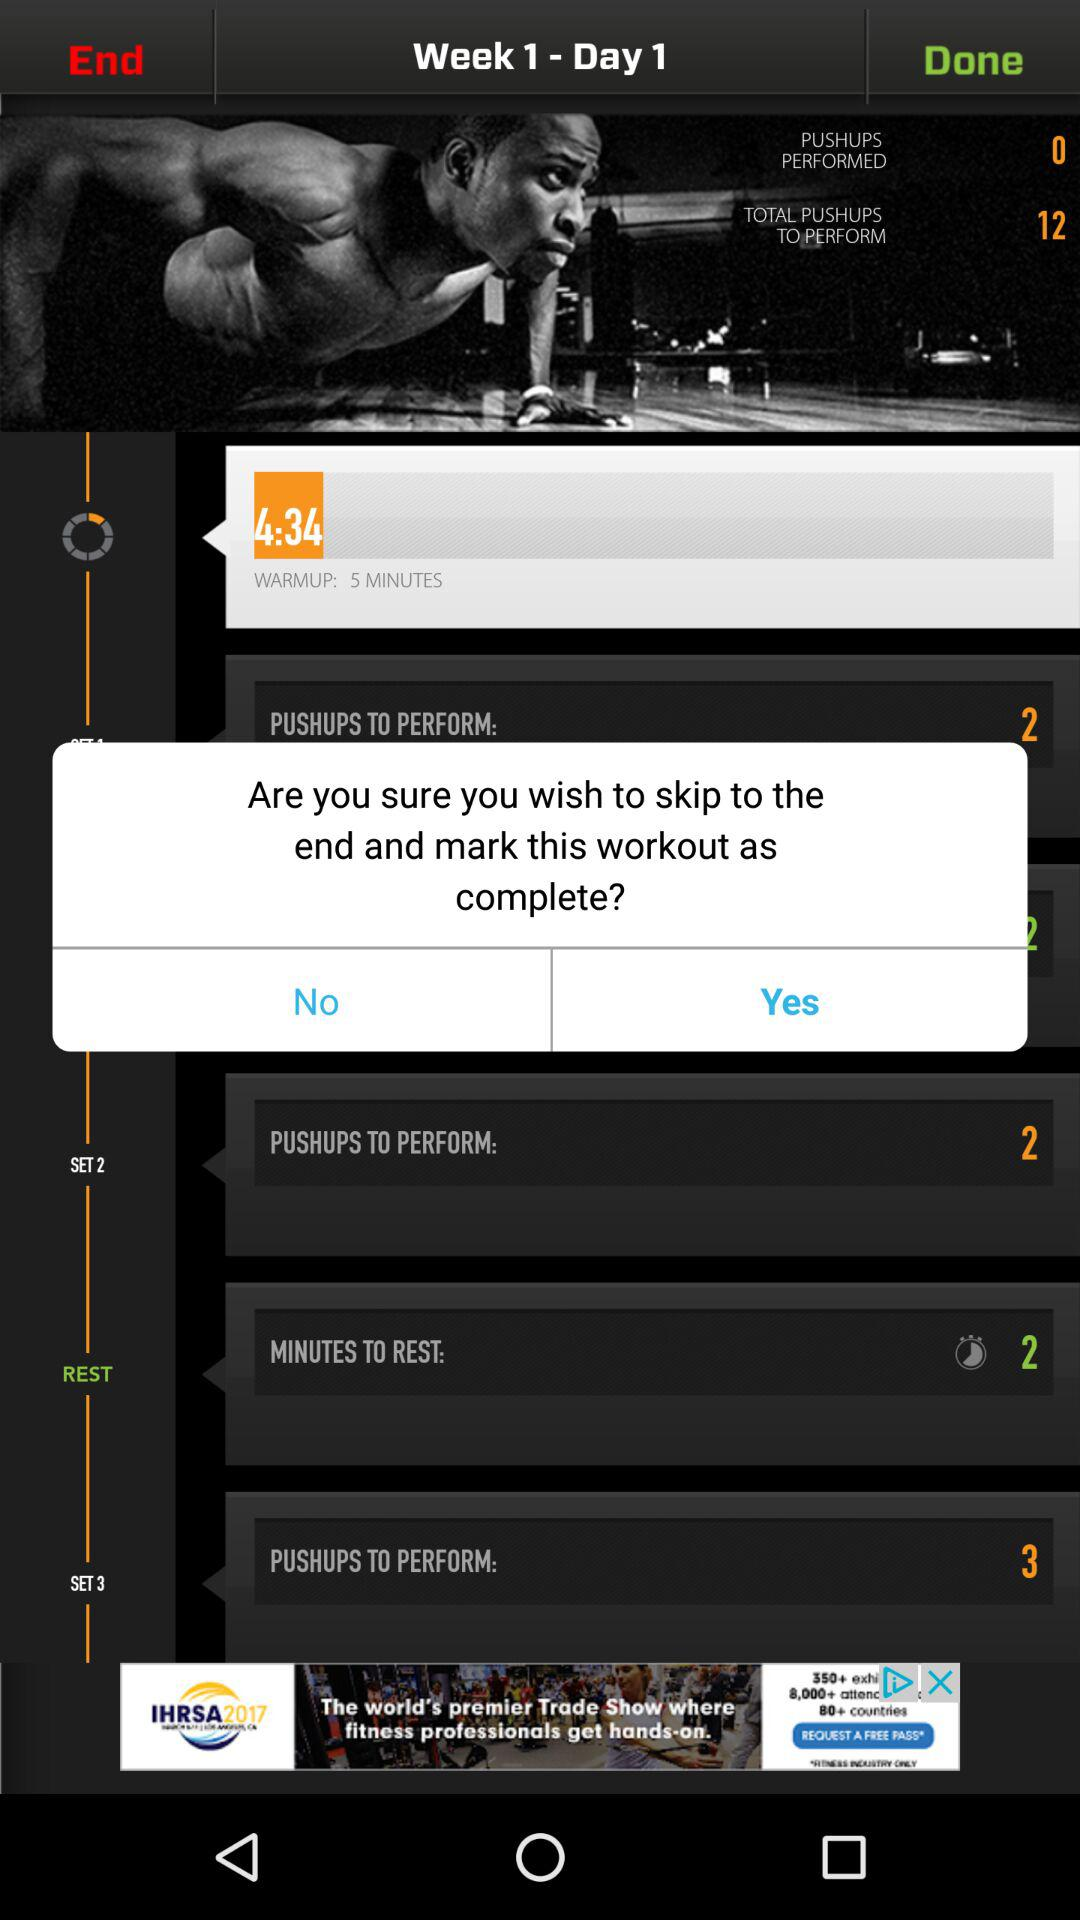How many pushups are there to perform in set 3? There are 3 pushups to perform in set 3. 